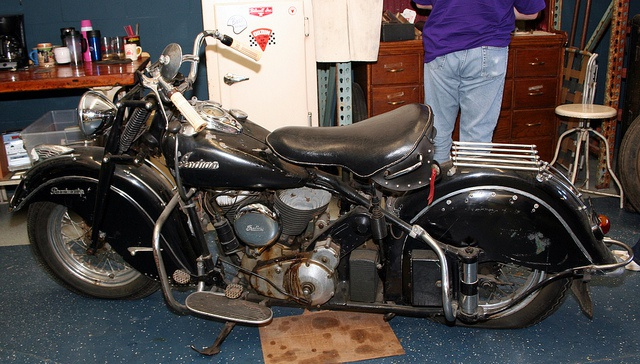Describe the objects in this image and their specific colors. I can see motorcycle in black, gray, and darkgray tones, people in black, darkgray, navy, and gray tones, chair in black, gray, maroon, and tan tones, cup in black, navy, gray, and blue tones, and cup in black, maroon, gray, and darkgray tones in this image. 